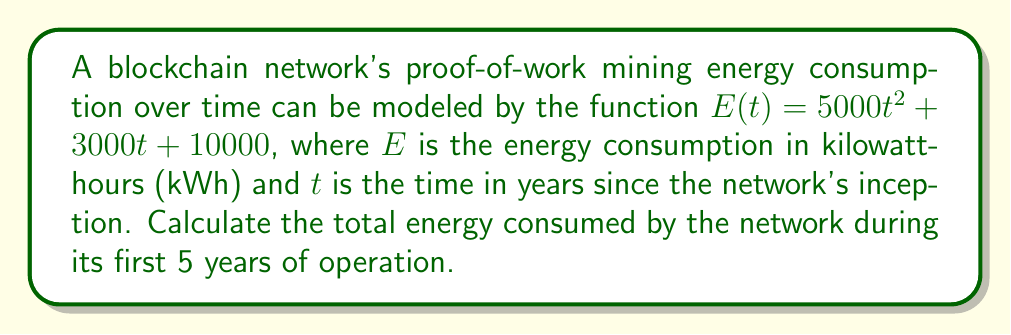Could you help me with this problem? To find the total energy consumed over the first 5 years, we need to calculate the area under the curve of $E(t)$ from $t=0$ to $t=5$. This can be done using definite integration.

1. Set up the definite integral:
   $$\int_0^5 (5000t^2 + 3000t + 10000) dt$$

2. Integrate the function:
   $$\left[ \frac{5000t^3}{3} + \frac{3000t^2}{2} + 10000t \right]_0^5$$

3. Evaluate the integral at the upper and lower bounds:
   $$\left(\frac{5000(5^3)}{3} + \frac{3000(5^2)}{2} + 10000(5)\right) - \left(\frac{5000(0^3)}{3} + \frac{3000(0^2)}{2} + 10000(0)\right)$$

4. Simplify:
   $$\left(\frac{625000}{3} + 37500 + 50000\right) - (0)$$
   
   $$\approx 295,833.33$$

The result is in kilowatt-hours (kWh).
Answer: The total energy consumed by the blockchain network during its first 5 years of operation is approximately 295,833.33 kWh. 